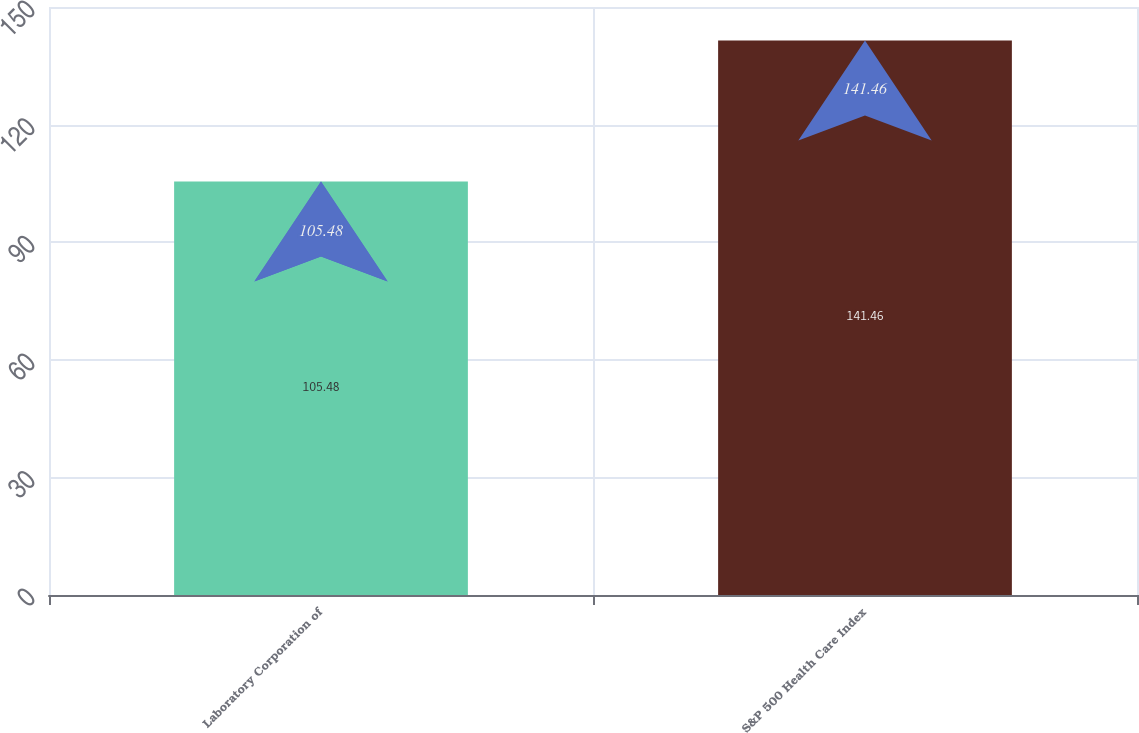<chart> <loc_0><loc_0><loc_500><loc_500><bar_chart><fcel>Laboratory Corporation of<fcel>S&P 500 Health Care Index<nl><fcel>105.48<fcel>141.46<nl></chart> 